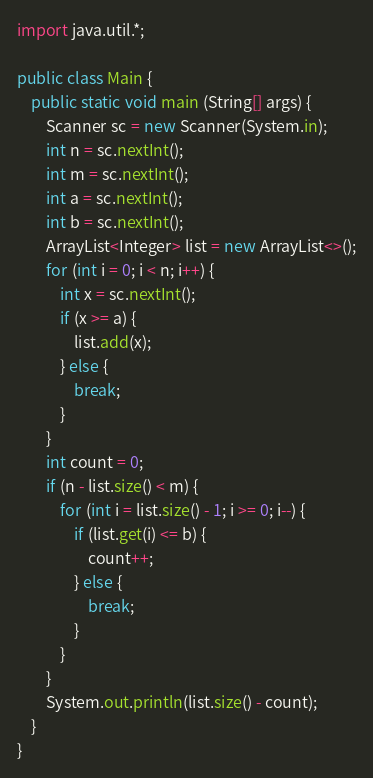<code> <loc_0><loc_0><loc_500><loc_500><_Java_>import java.util.*;

public class Main {
	public static void main (String[] args) {
		Scanner sc = new Scanner(System.in);
		int n = sc.nextInt();
		int m = sc.nextInt();
		int a = sc.nextInt();
		int b = sc.nextInt();
		ArrayList<Integer> list = new ArrayList<>();
		for (int i = 0; i < n; i++) {
		    int x = sc.nextInt();
		    if (x >= a) {
		        list.add(x);
		    } else {
		        break;
		    }
		}
		int count = 0;
		if (n - list.size() < m) {
		    for (int i = list.size() - 1; i >= 0; i--) {
		        if (list.get(i) <= b) {
		            count++;
		        } else {
		            break;
		        }
		    }
		}
		System.out.println(list.size() - count);
	}
}

</code> 